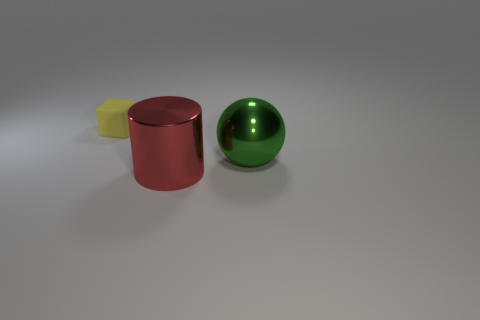Is there anything else that has the same size as the rubber thing?
Keep it short and to the point. No. Are there any balls that have the same material as the large red cylinder?
Provide a short and direct response. Yes. How many spheres are small blue metal things or yellow things?
Provide a succinct answer. 0. Are there any things that are to the left of the thing right of the metal cylinder?
Provide a succinct answer. Yes. Is the number of large spheres less than the number of red cubes?
Offer a terse response. No. What number of big green objects are the same shape as the small object?
Provide a short and direct response. 0. What number of red objects are either metallic cylinders or large things?
Ensure brevity in your answer.  1. There is a thing that is on the right side of the shiny object that is left of the green thing; what size is it?
Your response must be concise. Large. How many red cylinders have the same size as the yellow cube?
Make the answer very short. 0. Is the yellow object the same size as the green metal object?
Offer a terse response. No. 